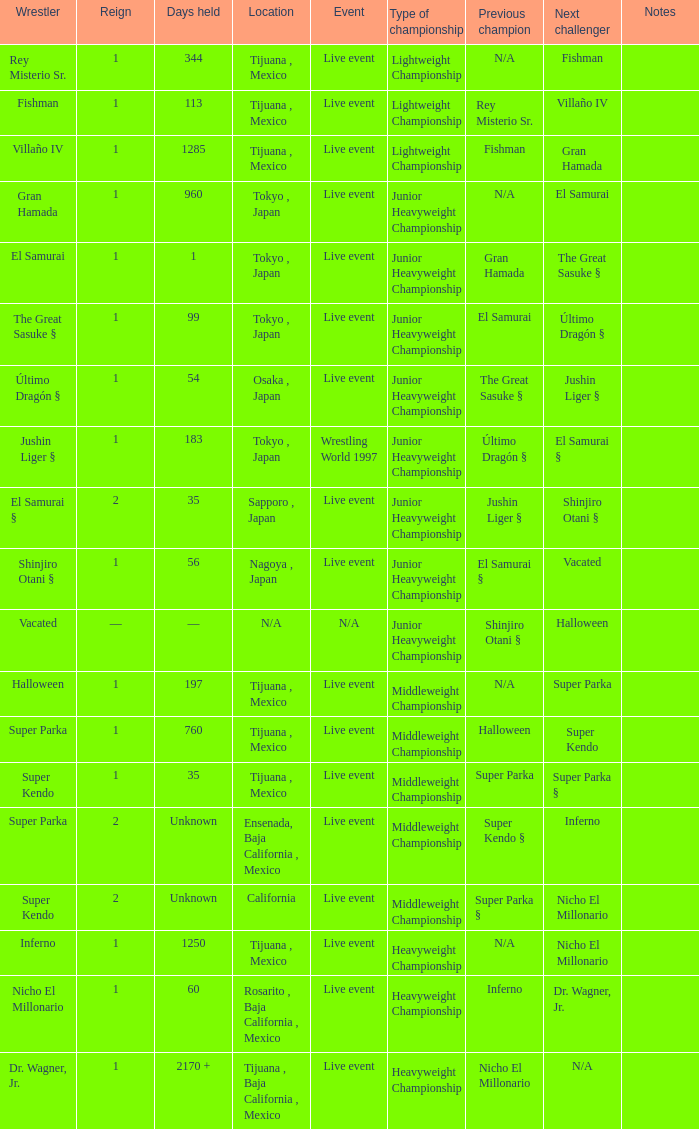What type of event had the wrestler with a reign of 2 and held the title for 35 days? Live event. 